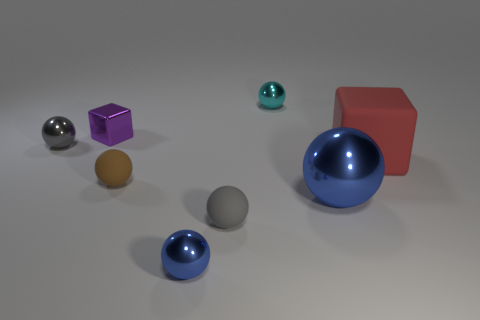Subtract 3 spheres. How many spheres are left? 3 Subtract all brown spheres. How many spheres are left? 5 Subtract all cyan spheres. How many spheres are left? 5 Subtract all brown spheres. Subtract all yellow cubes. How many spheres are left? 5 Add 1 red cubes. How many objects exist? 9 Subtract all spheres. How many objects are left? 2 Subtract all small brown matte things. Subtract all gray rubber objects. How many objects are left? 6 Add 2 gray metallic balls. How many gray metallic balls are left? 3 Add 1 big blue balls. How many big blue balls exist? 2 Subtract 0 red spheres. How many objects are left? 8 